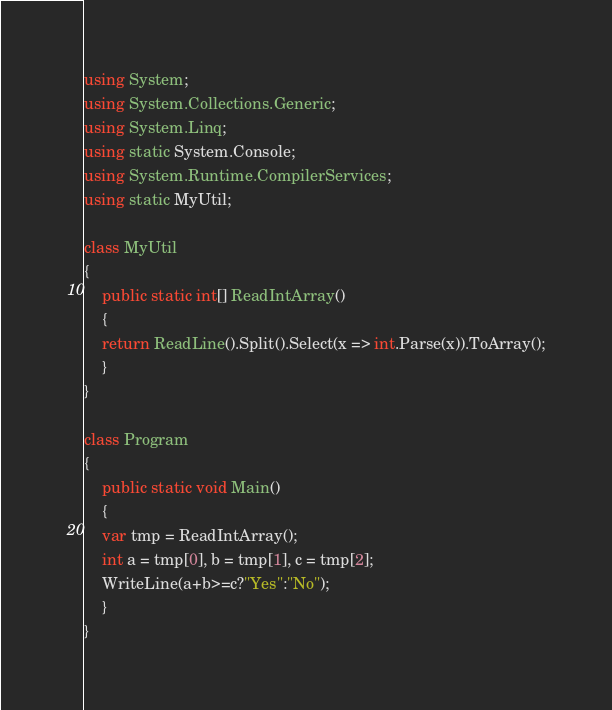Convert code to text. <code><loc_0><loc_0><loc_500><loc_500><_C#_>using System;
using System.Collections.Generic;
using System.Linq;
using static System.Console;
using System.Runtime.CompilerServices;
using static MyUtil;

class MyUtil
{
    public static int[] ReadIntArray()
    {
	return ReadLine().Split().Select(x => int.Parse(x)).ToArray();
    }
}

class Program
{
    public static void Main()
    {
	var tmp = ReadIntArray();
	int a = tmp[0], b = tmp[1], c = tmp[2];
	WriteLine(a+b>=c?"Yes":"No");
    }
}
</code> 